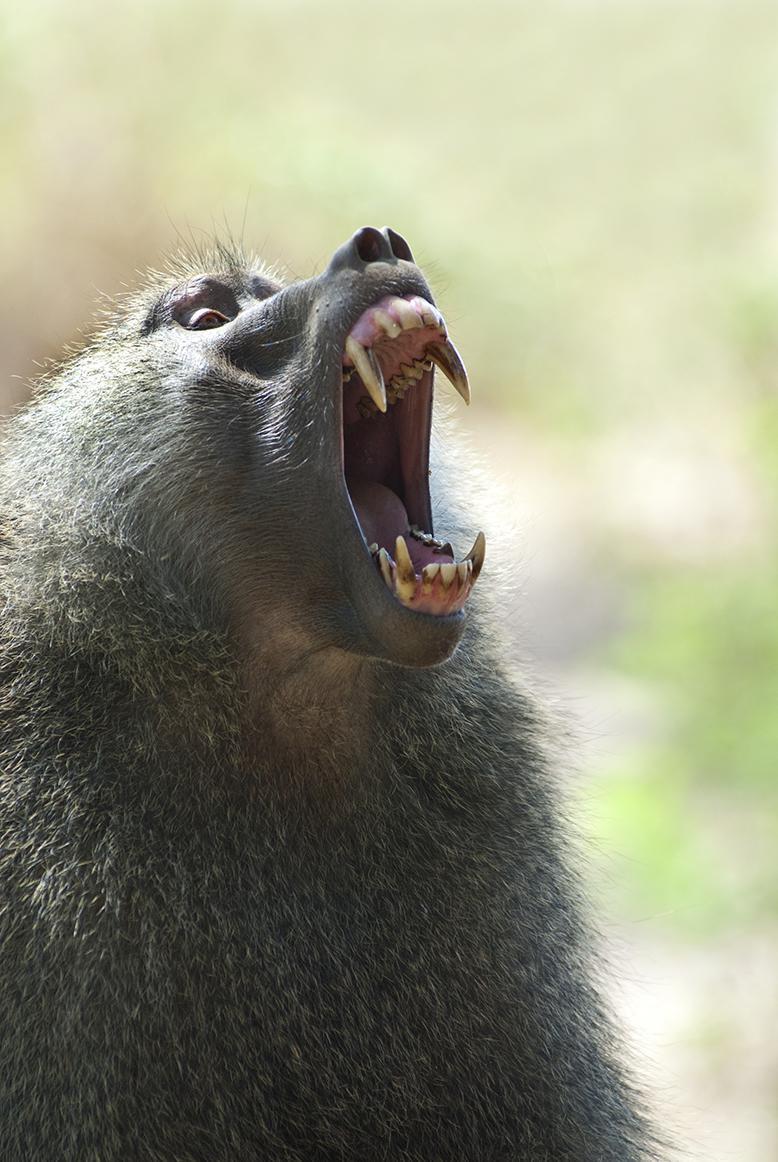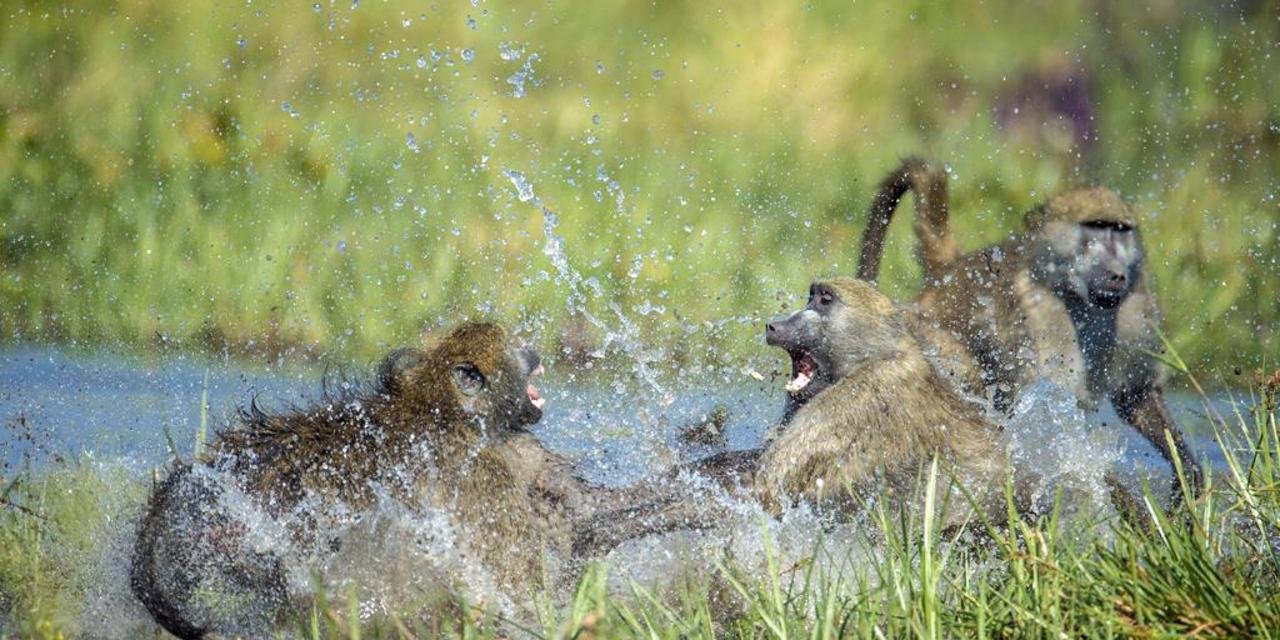The first image is the image on the left, the second image is the image on the right. Considering the images on both sides, is "An image contains exactly one primate." valid? Answer yes or no. Yes. 